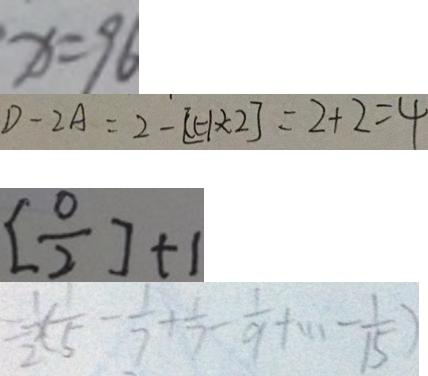<formula> <loc_0><loc_0><loc_500><loc_500>x = 9 6 
 D - 2 A = 2 - [ ( - 1 ) \times 2 ] = 2 + 2 = 4 
 [ \frac { 0 } { 2 } ] + 1 
 = \frac { 1 } { 2 } \times ( \frac { 1 } { 5 } - \frac { 1 } { 7 } + \frac { 1 } { 7 } - \frac { 1 } { 9 } + \cdots - \frac { 1 } { 1 5 } )</formula> 